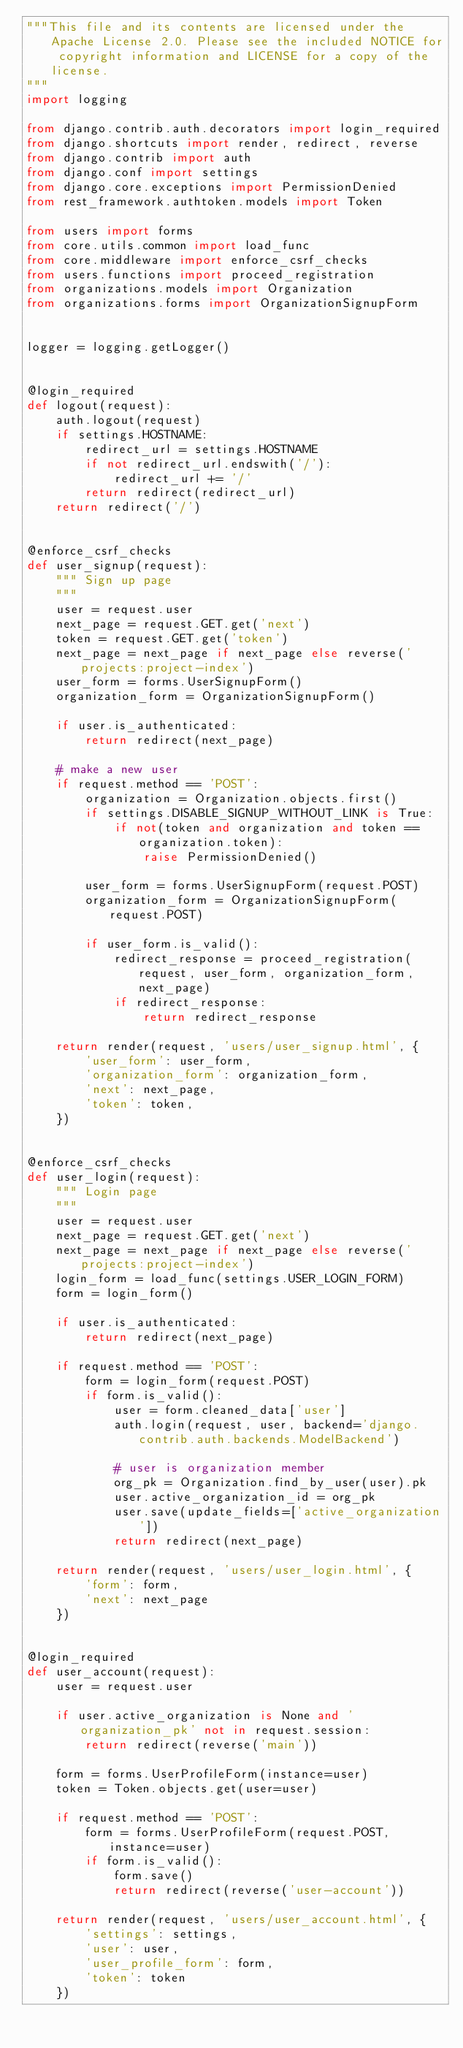Convert code to text. <code><loc_0><loc_0><loc_500><loc_500><_Python_>"""This file and its contents are licensed under the Apache License 2.0. Please see the included NOTICE for copyright information and LICENSE for a copy of the license.
"""
import logging

from django.contrib.auth.decorators import login_required
from django.shortcuts import render, redirect, reverse
from django.contrib import auth
from django.conf import settings
from django.core.exceptions import PermissionDenied
from rest_framework.authtoken.models import Token

from users import forms
from core.utils.common import load_func
from core.middleware import enforce_csrf_checks
from users.functions import proceed_registration
from organizations.models import Organization
from organizations.forms import OrganizationSignupForm


logger = logging.getLogger()


@login_required
def logout(request):
    auth.logout(request)
    if settings.HOSTNAME:
        redirect_url = settings.HOSTNAME
        if not redirect_url.endswith('/'):
            redirect_url += '/'
        return redirect(redirect_url)
    return redirect('/')


@enforce_csrf_checks
def user_signup(request):
    """ Sign up page
    """
    user = request.user
    next_page = request.GET.get('next')
    token = request.GET.get('token')
    next_page = next_page if next_page else reverse('projects:project-index')
    user_form = forms.UserSignupForm()
    organization_form = OrganizationSignupForm()

    if user.is_authenticated:
        return redirect(next_page)

    # make a new user
    if request.method == 'POST':
        organization = Organization.objects.first()
        if settings.DISABLE_SIGNUP_WITHOUT_LINK is True:
            if not(token and organization and token == organization.token):
                raise PermissionDenied()

        user_form = forms.UserSignupForm(request.POST)
        organization_form = OrganizationSignupForm(request.POST)

        if user_form.is_valid():
            redirect_response = proceed_registration(request, user_form, organization_form, next_page)
            if redirect_response:
                return redirect_response

    return render(request, 'users/user_signup.html', {
        'user_form': user_form,
        'organization_form': organization_form,
        'next': next_page,
        'token': token,
    })


@enforce_csrf_checks
def user_login(request):
    """ Login page
    """
    user = request.user
    next_page = request.GET.get('next')
    next_page = next_page if next_page else reverse('projects:project-index')
    login_form = load_func(settings.USER_LOGIN_FORM)
    form = login_form()

    if user.is_authenticated:
        return redirect(next_page)

    if request.method == 'POST':
        form = login_form(request.POST)
        if form.is_valid():
            user = form.cleaned_data['user']
            auth.login(request, user, backend='django.contrib.auth.backends.ModelBackend')

            # user is organization member
            org_pk = Organization.find_by_user(user).pk
            user.active_organization_id = org_pk
            user.save(update_fields=['active_organization'])
            return redirect(next_page)

    return render(request, 'users/user_login.html', {
        'form': form,
        'next': next_page
    })


@login_required
def user_account(request):
    user = request.user

    if user.active_organization is None and 'organization_pk' not in request.session:
        return redirect(reverse('main'))

    form = forms.UserProfileForm(instance=user)
    token = Token.objects.get(user=user)

    if request.method == 'POST':
        form = forms.UserProfileForm(request.POST, instance=user)
        if form.is_valid():
            form.save()
            return redirect(reverse('user-account'))

    return render(request, 'users/user_account.html', {
        'settings': settings,
        'user': user,
        'user_profile_form': form,
        'token': token
    })
</code> 